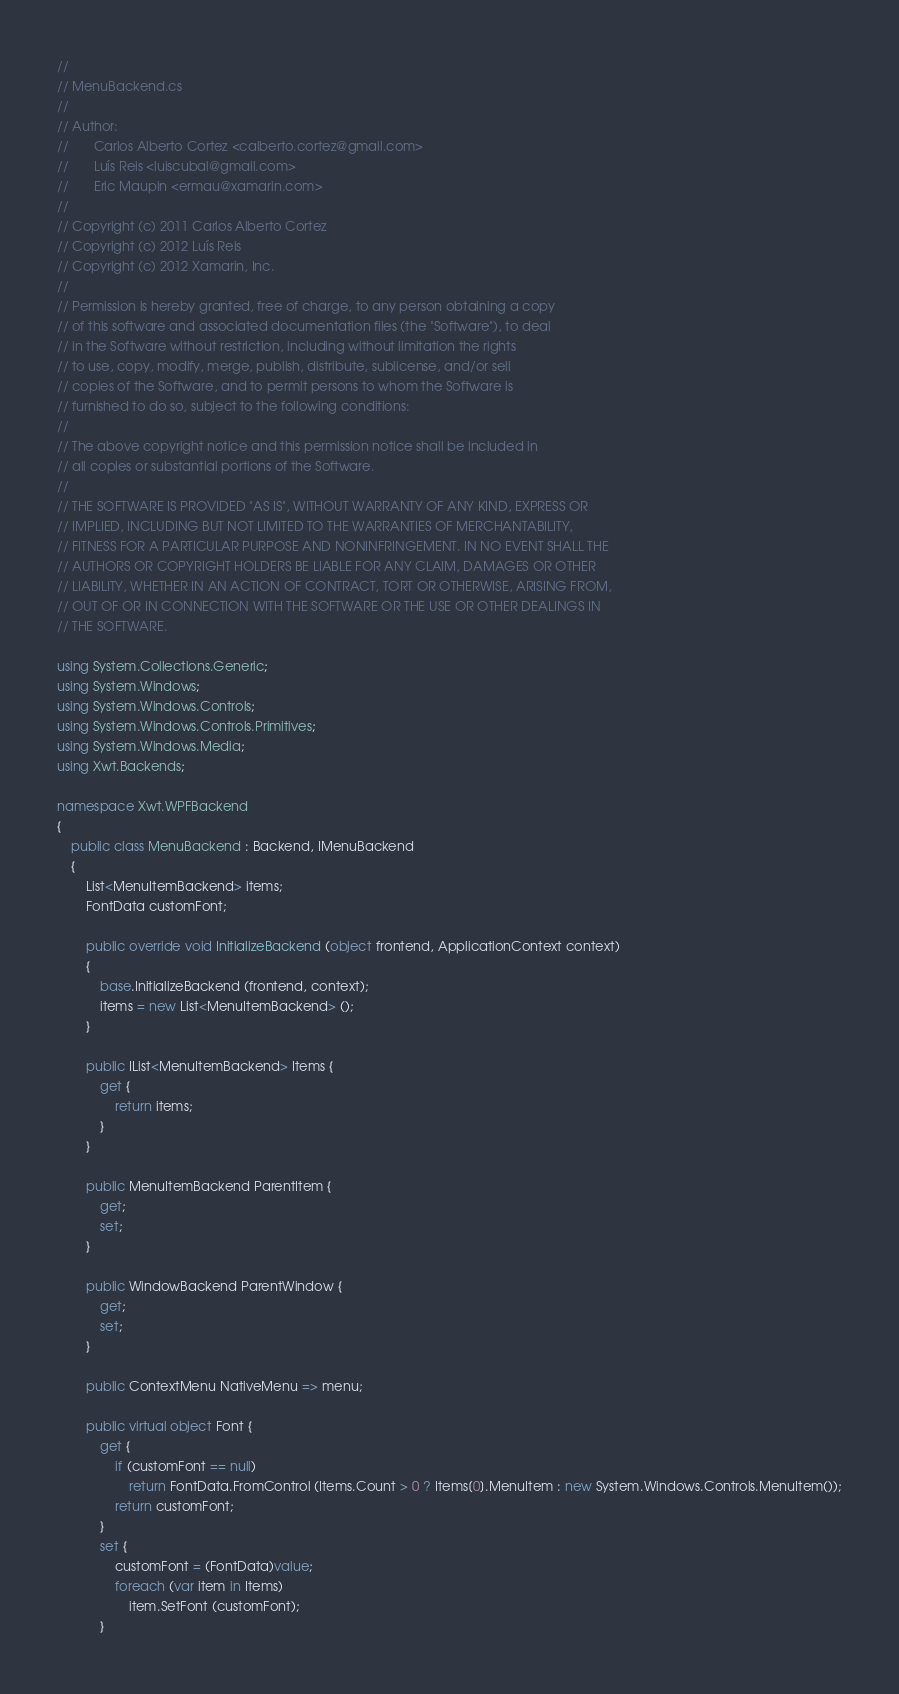Convert code to text. <code><loc_0><loc_0><loc_500><loc_500><_C#_>// 
// MenuBackend.cs
//  
// Author:
//       Carlos Alberto Cortez <calberto.cortez@gmail.com>
//       Luís Reis <luiscubal@gmail.com>
//       Eric Maupin <ermau@xamarin.com>
// 
// Copyright (c) 2011 Carlos Alberto Cortez
// Copyright (c) 2012 Luís Reis
// Copyright (c) 2012 Xamarin, Inc.
// 
// Permission is hereby granted, free of charge, to any person obtaining a copy
// of this software and associated documentation files (the "Software"), to deal
// in the Software without restriction, including without limitation the rights
// to use, copy, modify, merge, publish, distribute, sublicense, and/or sell
// copies of the Software, and to permit persons to whom the Software is
// furnished to do so, subject to the following conditions:
// 
// The above copyright notice and this permission notice shall be included in
// all copies or substantial portions of the Software.
// 
// THE SOFTWARE IS PROVIDED "AS IS", WITHOUT WARRANTY OF ANY KIND, EXPRESS OR
// IMPLIED, INCLUDING BUT NOT LIMITED TO THE WARRANTIES OF MERCHANTABILITY,
// FITNESS FOR A PARTICULAR PURPOSE AND NONINFRINGEMENT. IN NO EVENT SHALL THE
// AUTHORS OR COPYRIGHT HOLDERS BE LIABLE FOR ANY CLAIM, DAMAGES OR OTHER
// LIABILITY, WHETHER IN AN ACTION OF CONTRACT, TORT OR OTHERWISE, ARISING FROM,
// OUT OF OR IN CONNECTION WITH THE SOFTWARE OR THE USE OR OTHER DEALINGS IN
// THE SOFTWARE.

using System.Collections.Generic;
using System.Windows;
using System.Windows.Controls;
using System.Windows.Controls.Primitives;
using System.Windows.Media;
using Xwt.Backends;

namespace Xwt.WPFBackend
{
	public class MenuBackend : Backend, IMenuBackend
	{
		List<MenuItemBackend> items;
		FontData customFont;

		public override void InitializeBackend (object frontend, ApplicationContext context)
		{
			base.InitializeBackend (frontend, context);
			items = new List<MenuItemBackend> ();
		}

		public IList<MenuItemBackend> Items {
			get {
				return items;
			}
		}

		public MenuItemBackend ParentItem {
			get;
			set;
		}

		public WindowBackend ParentWindow {
			get;
			set;
		}

		public ContextMenu NativeMenu => menu;

		public virtual object Font {
			get {
				if (customFont == null)
					return FontData.FromControl (Items.Count > 0 ? Items[0].MenuItem : new System.Windows.Controls.MenuItem());
				return customFont;
			}
			set {
				customFont = (FontData)value;
				foreach (var item in Items)
					item.SetFont (customFont);
			}</code> 